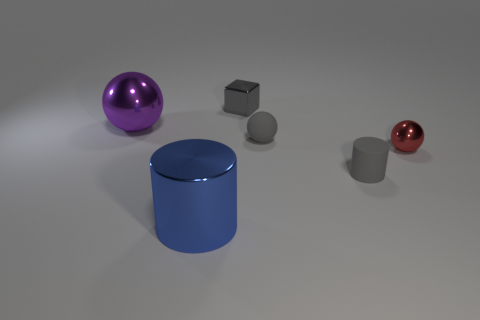Is there any other thing that has the same shape as the small gray shiny object?
Offer a terse response. No. There is a blue metal thing; are there any large objects behind it?
Your answer should be very brief. Yes. Is the size of the cube the same as the purple thing?
Ensure brevity in your answer.  No. What is the shape of the tiny shiny thing that is right of the small rubber cylinder?
Provide a short and direct response. Sphere. Is there a shiny ball that has the same size as the gray cylinder?
Your answer should be compact. Yes. There is a blue thing that is the same size as the purple metal object; what is it made of?
Provide a succinct answer. Metal. There is a sphere that is left of the block; what is its size?
Keep it short and to the point. Large. The blue cylinder has what size?
Ensure brevity in your answer.  Large. There is a matte cylinder; is it the same size as the gray matte thing behind the tiny red sphere?
Provide a short and direct response. Yes. What color is the small metallic object left of the tiny gray thing in front of the small rubber sphere?
Offer a terse response. Gray. 